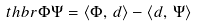Convert formula to latex. <formula><loc_0><loc_0><loc_500><loc_500>\ t h b r { \Phi } { \Psi } = \langle \Phi , \, d \rangle - \langle d , \, \Psi \rangle</formula> 